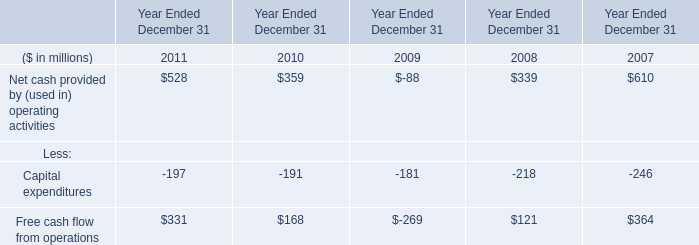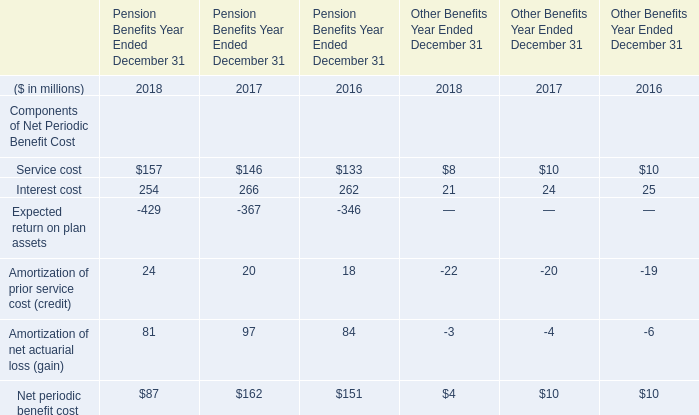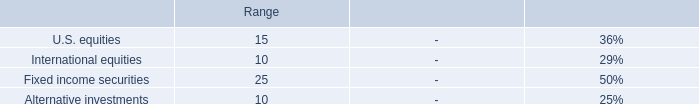What's the 30% of total elements for Pension Benefits Year Ended December 31 in 2018? (in million) 
Computations: (87 * 0.3)
Answer: 26.1. 